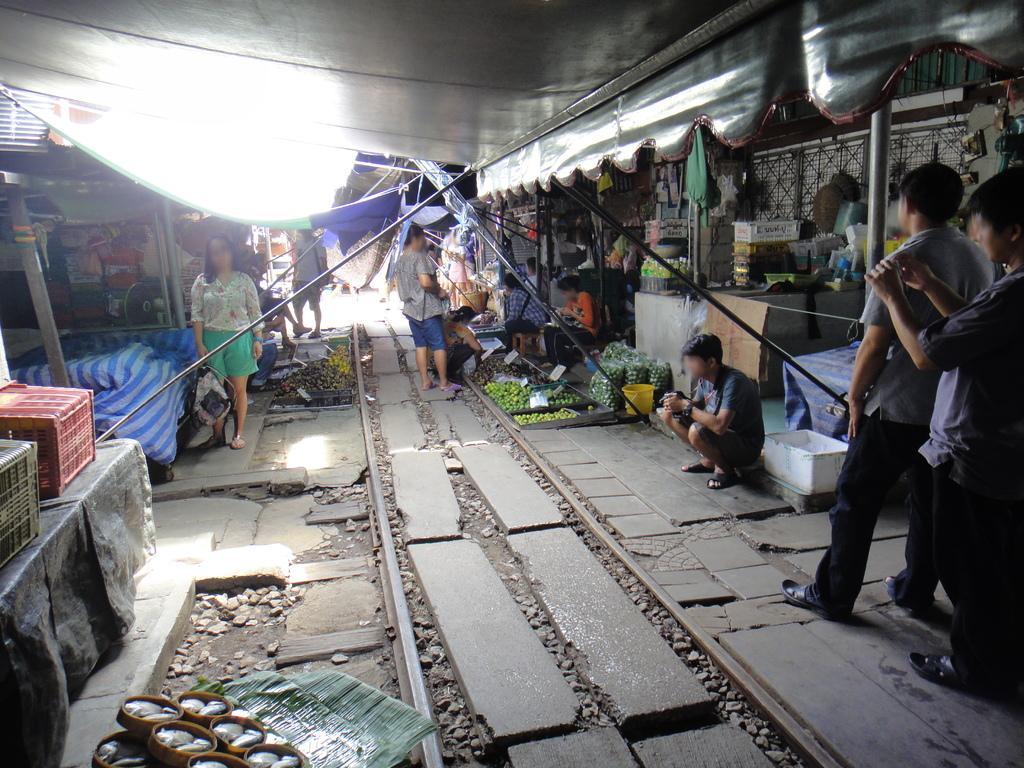How would you summarize this image in a sentence or two? At the bottom left side of the image we can see leaves and small baskets with some objects in it. In the center of the image we can see stones and a railway track. On the right side of the image, we can see two persons are standing. Among them, we can see one person is holding some object. On the left side of the image, we can see a table. On the table, we can see a plastic black cover and baskets. In the background there is a wall, bucket, cloth, curtains, vegetables, baskets, containers, few people are sitting, few people are standing, few people are holding some object and a few other objects. 